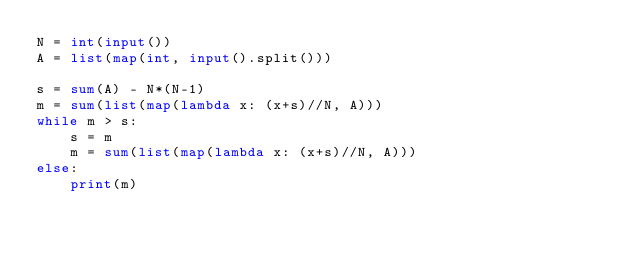Convert code to text. <code><loc_0><loc_0><loc_500><loc_500><_Python_>N = int(input())
A = list(map(int, input().split()))

s = sum(A) - N*(N-1)
m = sum(list(map(lambda x: (x+s)//N, A)))
while m > s:
    s = m
    m = sum(list(map(lambda x: (x+s)//N, A)))
else:
    print(m)</code> 